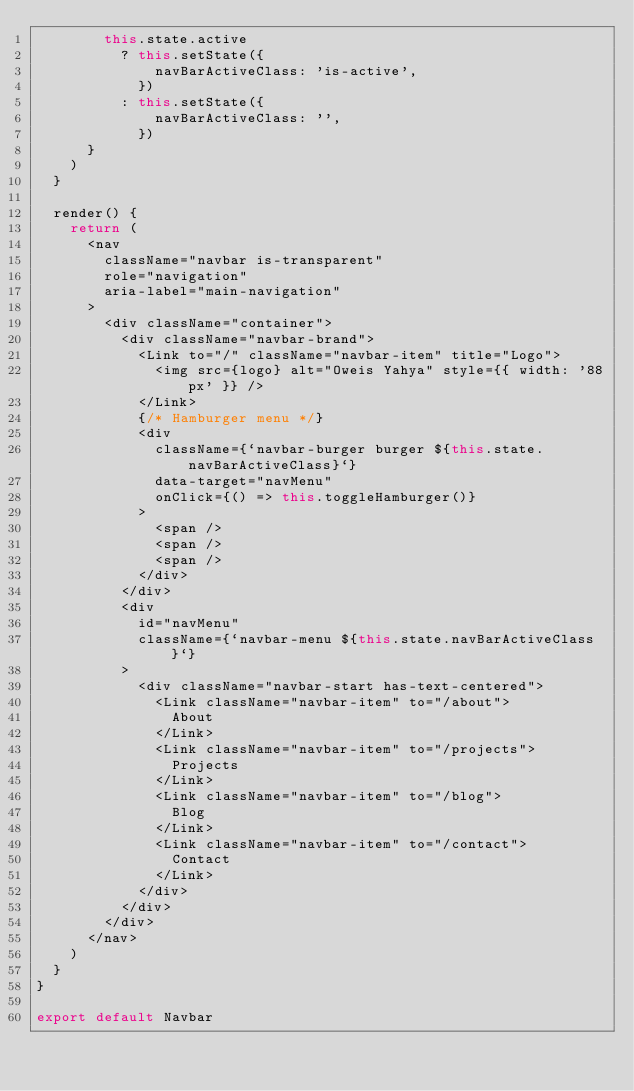<code> <loc_0><loc_0><loc_500><loc_500><_JavaScript_>        this.state.active
          ? this.setState({
              navBarActiveClass: 'is-active',
            })
          : this.setState({
              navBarActiveClass: '',
            })
      }
    )
  }

  render() {
    return (
      <nav
        className="navbar is-transparent"
        role="navigation"
        aria-label="main-navigation"
      >
        <div className="container">
          <div className="navbar-brand">
            <Link to="/" className="navbar-item" title="Logo">
              <img src={logo} alt="Oweis Yahya" style={{ width: '88px' }} />
            </Link>
            {/* Hamburger menu */}
            <div
              className={`navbar-burger burger ${this.state.navBarActiveClass}`}
              data-target="navMenu"
              onClick={() => this.toggleHamburger()}
            >
              <span />
              <span />
              <span />
            </div>
          </div>
          <div
            id="navMenu"
            className={`navbar-menu ${this.state.navBarActiveClass}`}
          >
            <div className="navbar-start has-text-centered">
              <Link className="navbar-item" to="/about">
                About
              </Link>
              <Link className="navbar-item" to="/projects">
                Projects
              </Link>
              <Link className="navbar-item" to="/blog">
                Blog
              </Link>
              <Link className="navbar-item" to="/contact">
                Contact
              </Link>
            </div>
          </div>
        </div>
      </nav>
    )
  }
}

export default Navbar
</code> 